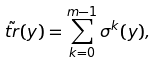Convert formula to latex. <formula><loc_0><loc_0><loc_500><loc_500>\tilde { t r } ( y ) = \sum _ { k = 0 } ^ { m - 1 } \sigma ^ { k } ( y ) ,</formula> 